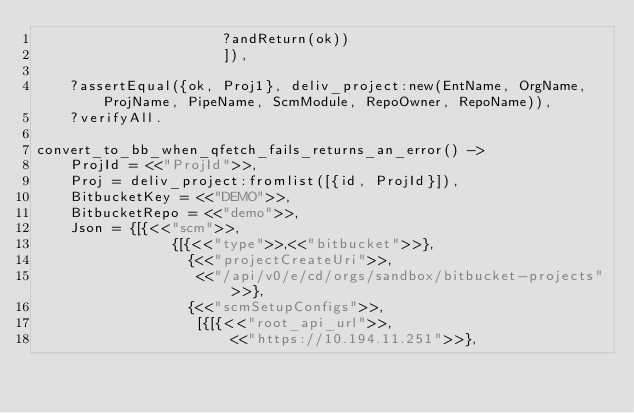<code> <loc_0><loc_0><loc_500><loc_500><_Erlang_>                      ?andReturn(ok))
                      ]),

    ?assertEqual({ok, Proj1}, deliv_project:new(EntName, OrgName, ProjName, PipeName, ScmModule, RepoOwner, RepoName)),
    ?verifyAll.

convert_to_bb_when_qfetch_fails_returns_an_error() ->
    ProjId = <<"ProjId">>,
    Proj = deliv_project:fromlist([{id, ProjId}]),
    BitbucketKey = <<"DEMO">>,
    BitbucketRepo = <<"demo">>,
    Json = {[{<<"scm">>,
                {[{<<"type">>,<<"bitbucket">>},
                  {<<"projectCreateUri">>,
                   <<"/api/v0/e/cd/orgs/sandbox/bitbucket-projects">>},
                  {<<"scmSetupConfigs">>,
                   [{[{<<"root_api_url">>,
                       <<"https://10.194.11.251">>},</code> 